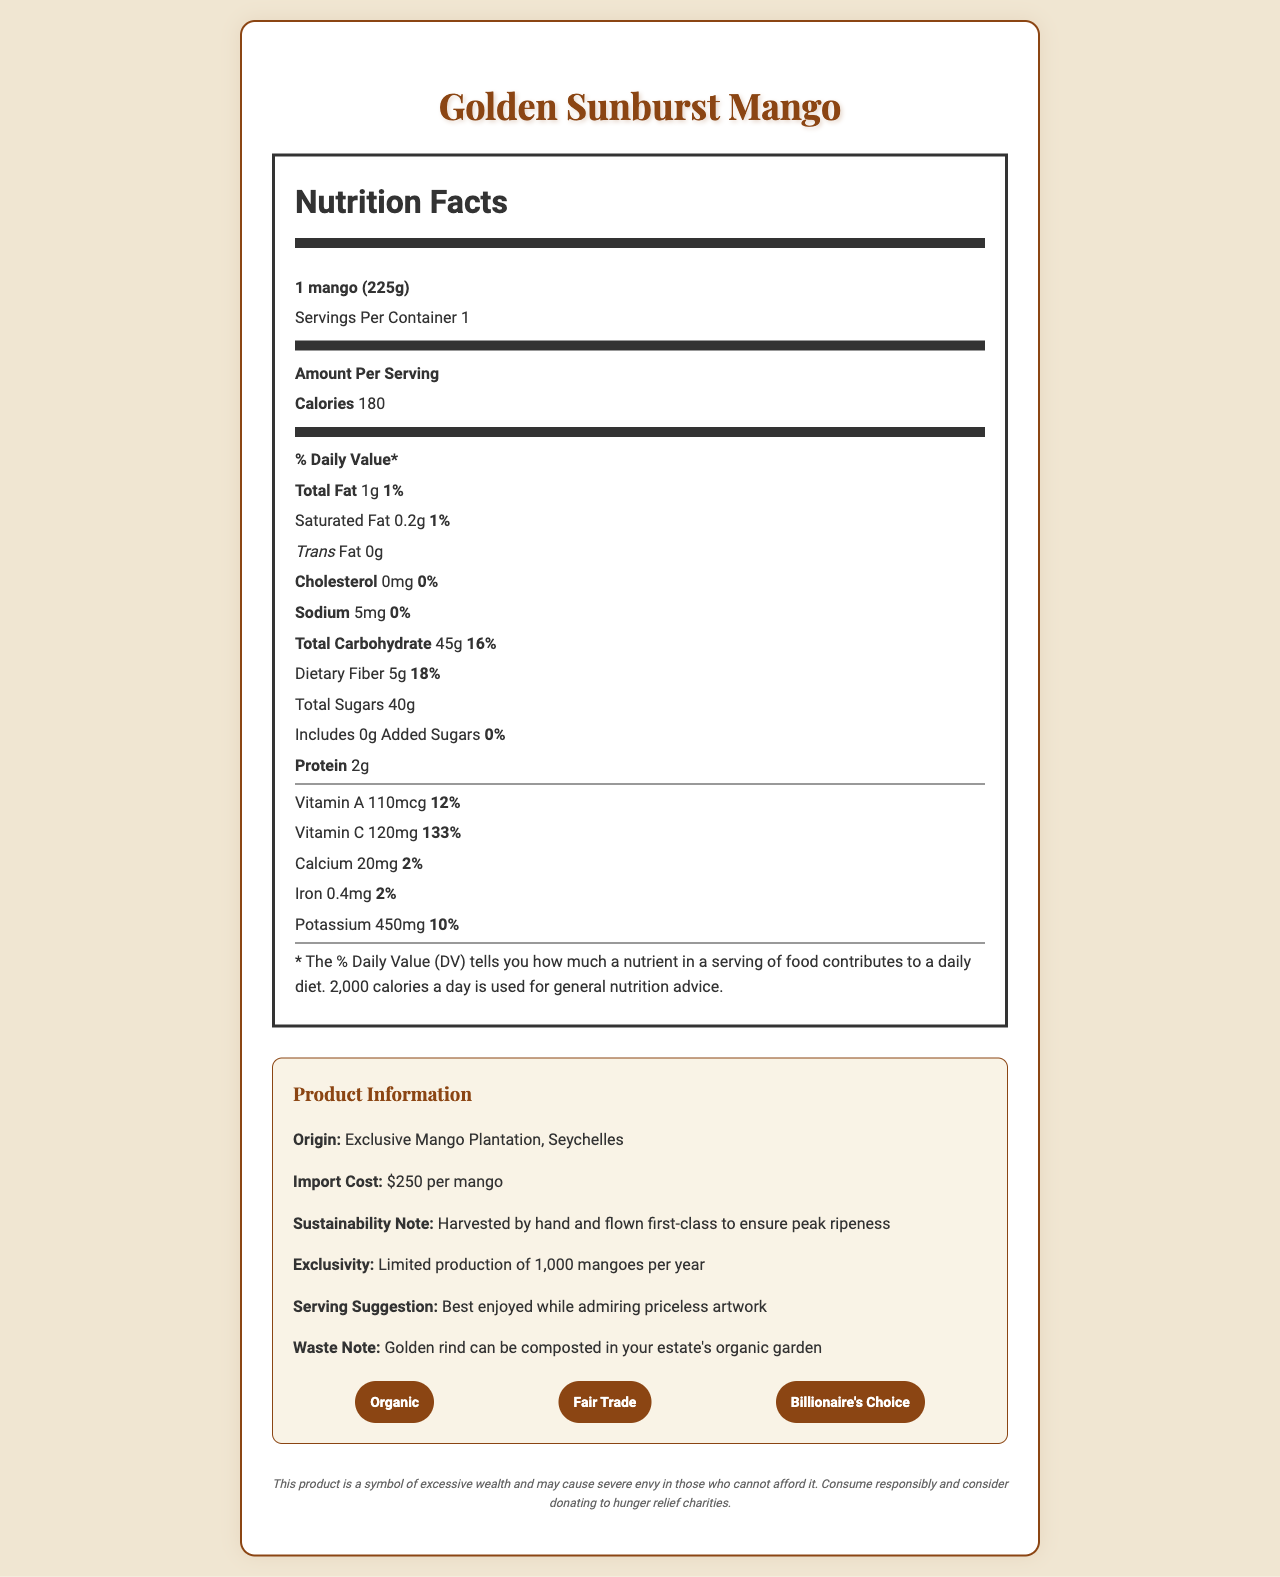What is the serving size for the Golden Sunburst Mango? The document specifies the serving size as "1 mango (225g)" in the nutrition facts section.
Answer: 1 mango (225g) How many calories are in one serving of the Golden Sunburst Mango? The document states that there are 180 calories per serving.
Answer: 180 What is the % Daily Value of Vitamin C in the Golden Sunburst Mango? The nutrition label indicates that the Vitamin C content per serving is 120mg, which is 133% of the Daily Value.
Answer: 133% Where is the Golden Sunburst Mango imported from? The Product Information section details that the origin is "Exclusive Mango Plantation, Seychelles."
Answer: Exclusive Mango Plantation, Seychelles What are the certifications mentioned for the Golden Sunburst Mango? The extra information section lists the certifications as "Organic," "Fair Trade," and "Billionaire's Choice."
Answer: Organic, Fair Trade, Billionaire's Choice What is the import cost for each Golden Sunburst Mango? The import cost is specified as "$250 per mango."
Answer: $250 per mango What is the total carbohydrate content in one serving? A) 20g B) 30g C) 45g D) 60g The document states that the total carbohydrate content is 45g per serving.
Answer: C) 45g How much dietary fiber does one mango contain? A. 2g B. 5g C. 8g D. 10g The document states the dietary fiber content is 5g per serving.
Answer: B. 5g Is there any cholesterol in the Golden Sunburst Mango? The nutrition label mentions that there is 0mg of cholesterol per serving.
Answer: No Summarize the main idea of the document. The document showcases both nutritional facts and elaborate details about the fruit’s exclusive production and high import cost. It highlights that it is organic, fair trade, and has limited availability.
Answer: The document provides detailed nutritional information for the Golden Sunburst Mango, an exotic fruit imported from Seychelles at a high cost, emphasizing its nutritional benefits, exclusive import details, and certifications. What is the % Daily Value of calcium per serving? The nutrition label specifies that the calcium content per serving is 20mg, which is 2% of the Daily Value.
Answer: 2% How many grams of protein are in one serving of the Golden Sunburst Mango? The nutrition facts section states that the protein content is 2g per serving.
Answer: 2g What is the suggested way to dispose of the golden rind of the mango? The Waste Note suggests the golden rind can be composted in an organic garden.
Answer: Compost it in your estate's organic garden What is the serving suggestion mentioned in the document? The serving suggestion in the Product Information section states, "Best enjoyed while admiring priceless artwork."
Answer: Best enjoyed while admiring priceless artwork Does the Golden Sunburst Mango contain any added sugars? The nutrition label indicates that the amount of added sugars is 0g.
Answer: No How is the Golden Sunburst Mango harvested and transported to ensure peak ripeness? The product's Sustainability Note mentions that it is "Harvested by hand and flown first-class to ensure peak ripeness."
Answer: Harvested by hand and flown first-class How many Golden Sunburst Mangoes are produced each year? The exclusivity claim states there is a limited production of 1,000 mangoes per year.
Answer: 1,000 What is the total fat content in one serving? The nutrition facts section lists the total fat content as 1g per serving.
Answer: 1g How much potassium is in one serving of the Golden Sunburst Mango? The nutrition facts label indicates that the potassium content is 450mg per serving.
Answer: 450mg How many servings are there per container? The document specifies that there is one serving per container.
Answer: 1 Why is the Golden Sunburst Mango referred to as "Billionaire's Choice"? The document does not provide a specific reason for why it is referred to as "Billionaire's Choice," only that it holds this certification. This can be considered marketing or exclusivity branding.
Answer: I don't know 